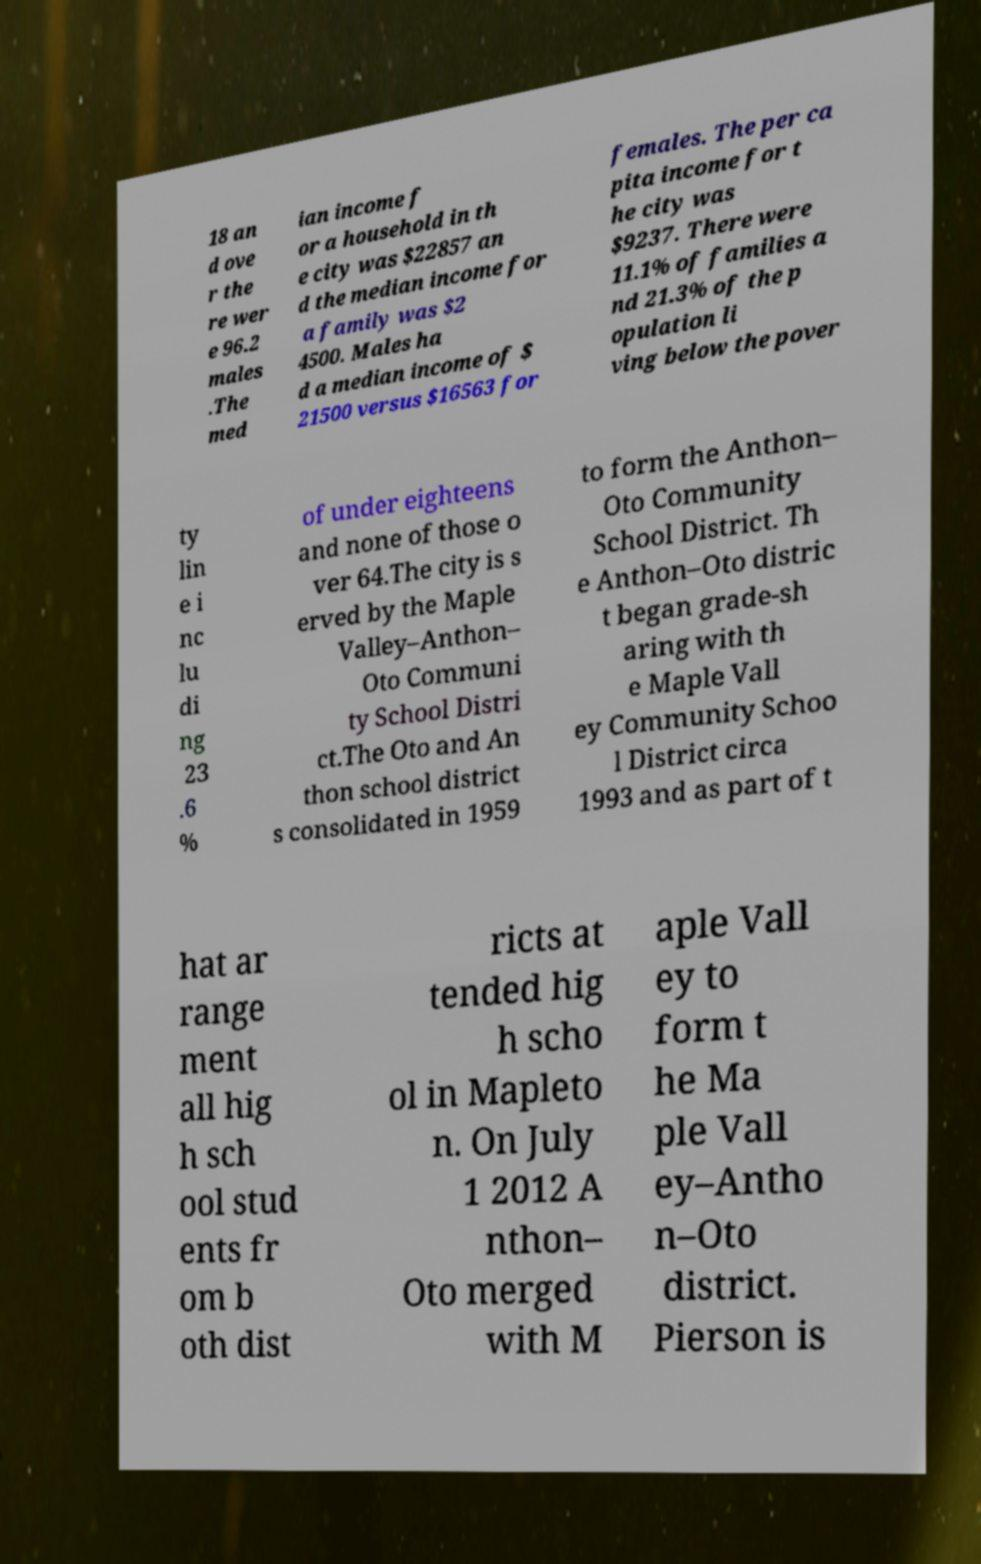For documentation purposes, I need the text within this image transcribed. Could you provide that? 18 an d ove r the re wer e 96.2 males .The med ian income f or a household in th e city was $22857 an d the median income for a family was $2 4500. Males ha d a median income of $ 21500 versus $16563 for females. The per ca pita income for t he city was $9237. There were 11.1% of families a nd 21.3% of the p opulation li ving below the pover ty lin e i nc lu di ng 23 .6 % of under eighteens and none of those o ver 64.The city is s erved by the Maple Valley–Anthon– Oto Communi ty School Distri ct.The Oto and An thon school district s consolidated in 1959 to form the Anthon– Oto Community School District. Th e Anthon–Oto distric t began grade-sh aring with th e Maple Vall ey Community Schoo l District circa 1993 and as part of t hat ar range ment all hig h sch ool stud ents fr om b oth dist ricts at tended hig h scho ol in Mapleto n. On July 1 2012 A nthon– Oto merged with M aple Vall ey to form t he Ma ple Vall ey–Antho n–Oto district. Pierson is 